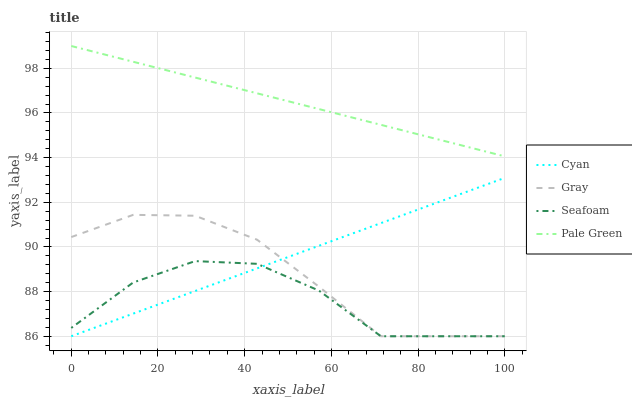Does Seafoam have the minimum area under the curve?
Answer yes or no. Yes. Does Pale Green have the maximum area under the curve?
Answer yes or no. Yes. Does Pale Green have the minimum area under the curve?
Answer yes or no. No. Does Seafoam have the maximum area under the curve?
Answer yes or no. No. Is Pale Green the smoothest?
Answer yes or no. Yes. Is Seafoam the roughest?
Answer yes or no. Yes. Is Seafoam the smoothest?
Answer yes or no. No. Is Pale Green the roughest?
Answer yes or no. No. Does Pale Green have the lowest value?
Answer yes or no. No. Does Pale Green have the highest value?
Answer yes or no. Yes. Does Seafoam have the highest value?
Answer yes or no. No. Is Cyan less than Pale Green?
Answer yes or no. Yes. Is Pale Green greater than Cyan?
Answer yes or no. Yes. Does Cyan intersect Gray?
Answer yes or no. Yes. Is Cyan less than Gray?
Answer yes or no. No. Is Cyan greater than Gray?
Answer yes or no. No. Does Cyan intersect Pale Green?
Answer yes or no. No. 